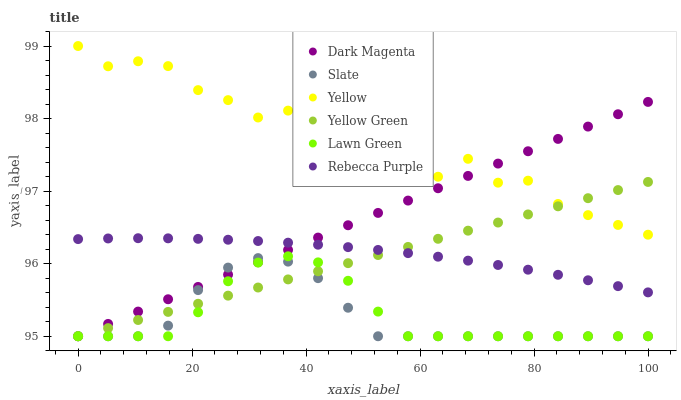Does Slate have the minimum area under the curve?
Answer yes or no. Yes. Does Yellow have the maximum area under the curve?
Answer yes or no. Yes. Does Dark Magenta have the minimum area under the curve?
Answer yes or no. No. Does Dark Magenta have the maximum area under the curve?
Answer yes or no. No. Is Yellow Green the smoothest?
Answer yes or no. Yes. Is Yellow the roughest?
Answer yes or no. Yes. Is Dark Magenta the smoothest?
Answer yes or no. No. Is Dark Magenta the roughest?
Answer yes or no. No. Does Lawn Green have the lowest value?
Answer yes or no. Yes. Does Yellow have the lowest value?
Answer yes or no. No. Does Yellow have the highest value?
Answer yes or no. Yes. Does Dark Magenta have the highest value?
Answer yes or no. No. Is Slate less than Rebecca Purple?
Answer yes or no. Yes. Is Rebecca Purple greater than Slate?
Answer yes or no. Yes. Does Lawn Green intersect Yellow Green?
Answer yes or no. Yes. Is Lawn Green less than Yellow Green?
Answer yes or no. No. Is Lawn Green greater than Yellow Green?
Answer yes or no. No. Does Slate intersect Rebecca Purple?
Answer yes or no. No. 